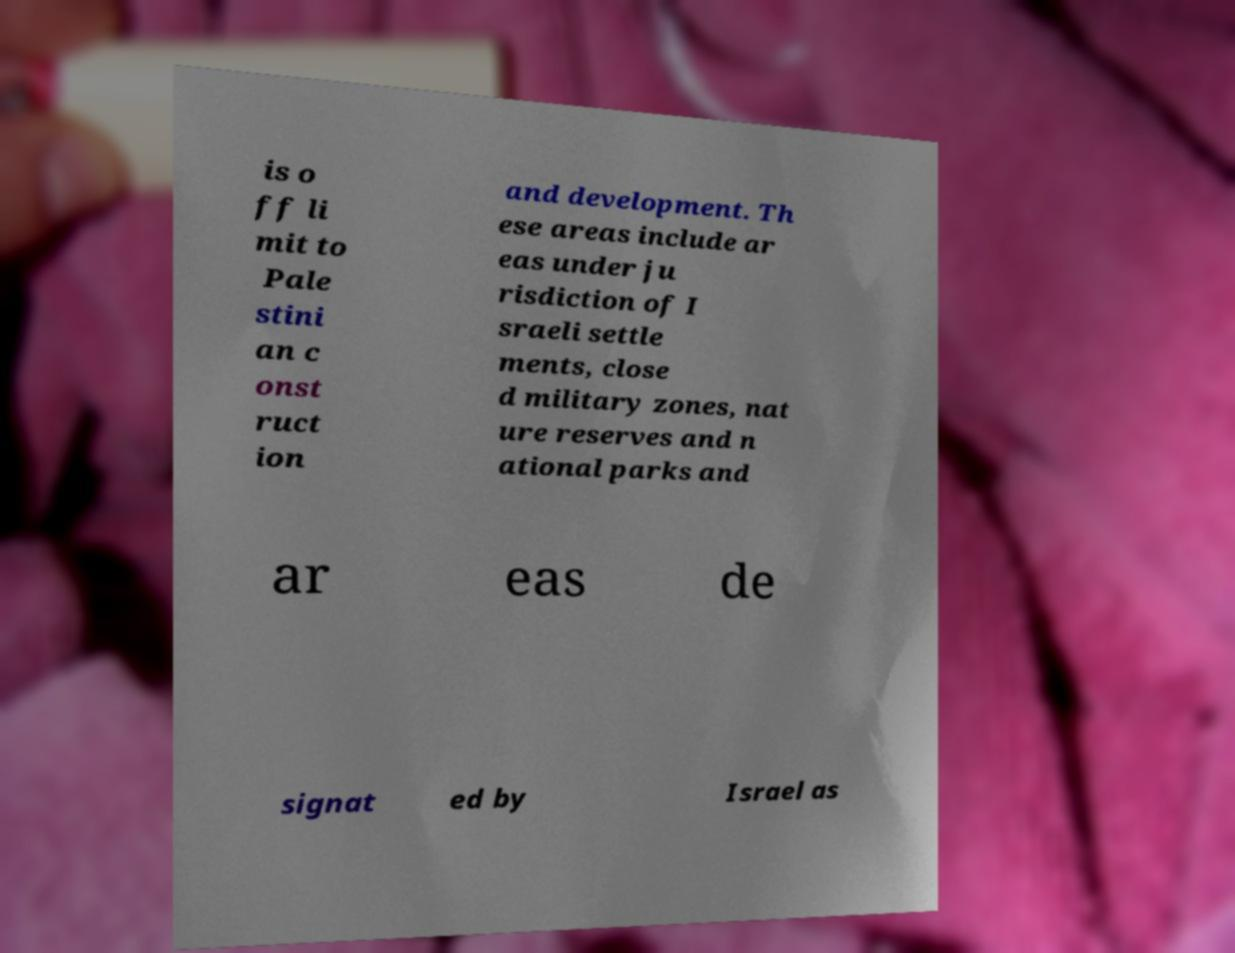Please read and relay the text visible in this image. What does it say? is o ff li mit to Pale stini an c onst ruct ion and development. Th ese areas include ar eas under ju risdiction of I sraeli settle ments, close d military zones, nat ure reserves and n ational parks and ar eas de signat ed by Israel as 